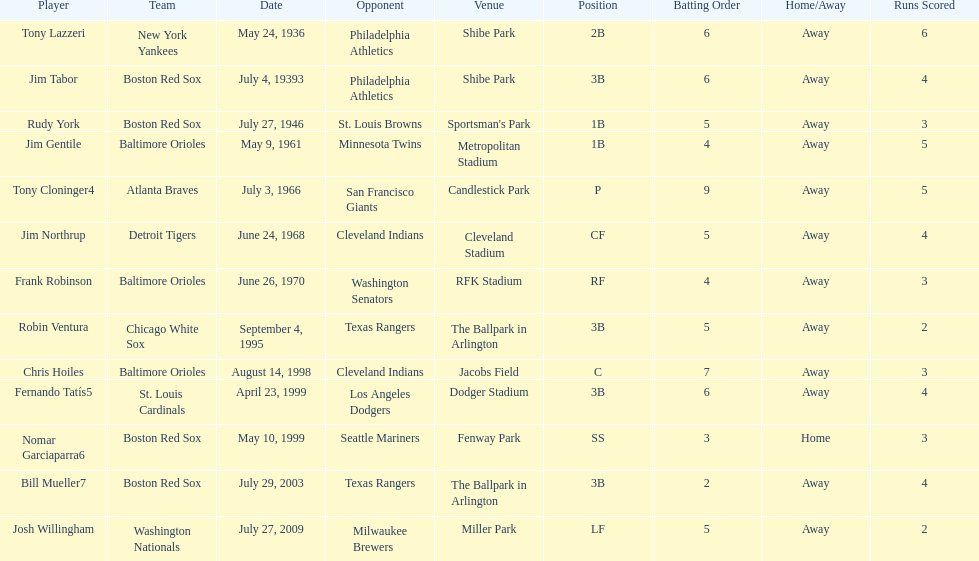Who is the first significant league hitter to strike two grand slams in one event? Tony Lazzeri. 